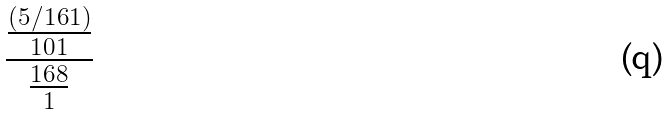Convert formula to latex. <formula><loc_0><loc_0><loc_500><loc_500>\frac { \frac { ( 5 / 1 6 1 ) } { 1 0 1 } } { \frac { 1 6 8 } { 1 } }</formula> 